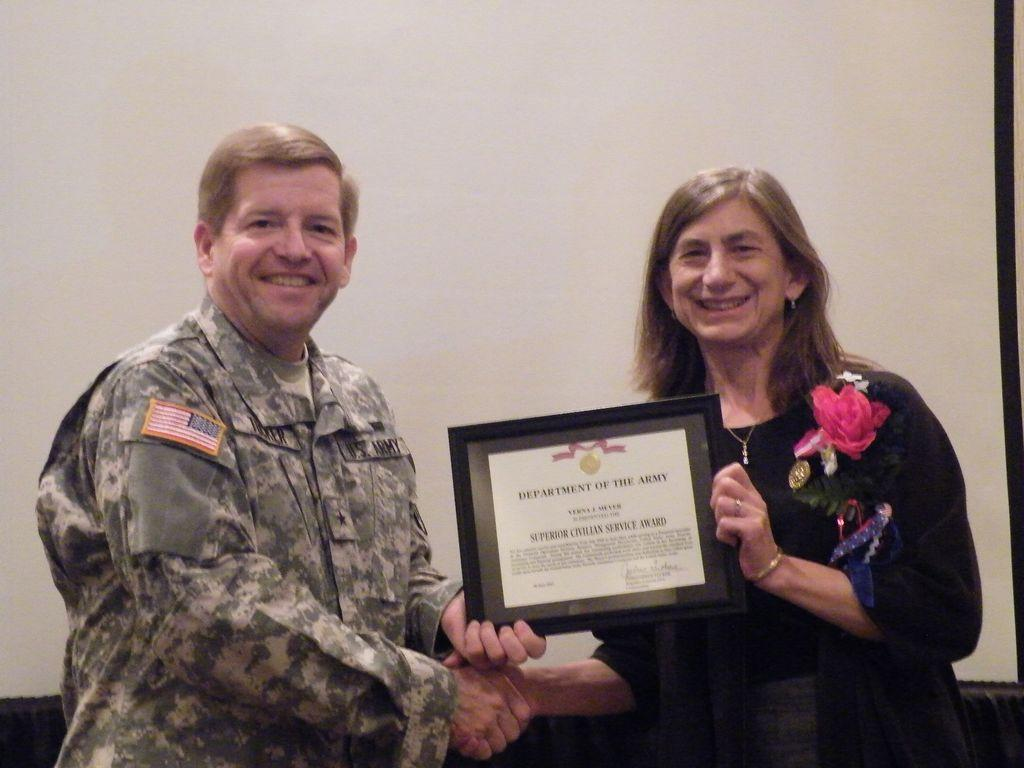How many people are present in the image? There are two people, a man and a woman, present in the image. What are the man and woman doing in the image? The man and woman are shaking hands and holding a frame in the image. What is the man wearing in the image? The man is wearing an army uniform in the image. What is the woman wearing in the image? The woman is wearing a black dress in the image. What can be seen in the background of the image? There is a wall visible in the background of the image. What type of government is depicted in the image? There is no depiction of a government in the image; it features a man and a woman shaking hands and holding a frame. How many lines can be seen on the van in the image? There is no van present in the image, so it is not possible to determine the number of lines on it. 